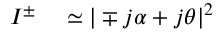<formula> <loc_0><loc_0><loc_500><loc_500>\begin{array} { r l } { I ^ { \pm } } & \simeq | \mp j \alpha + j \theta | ^ { 2 } } \end{array}</formula> 